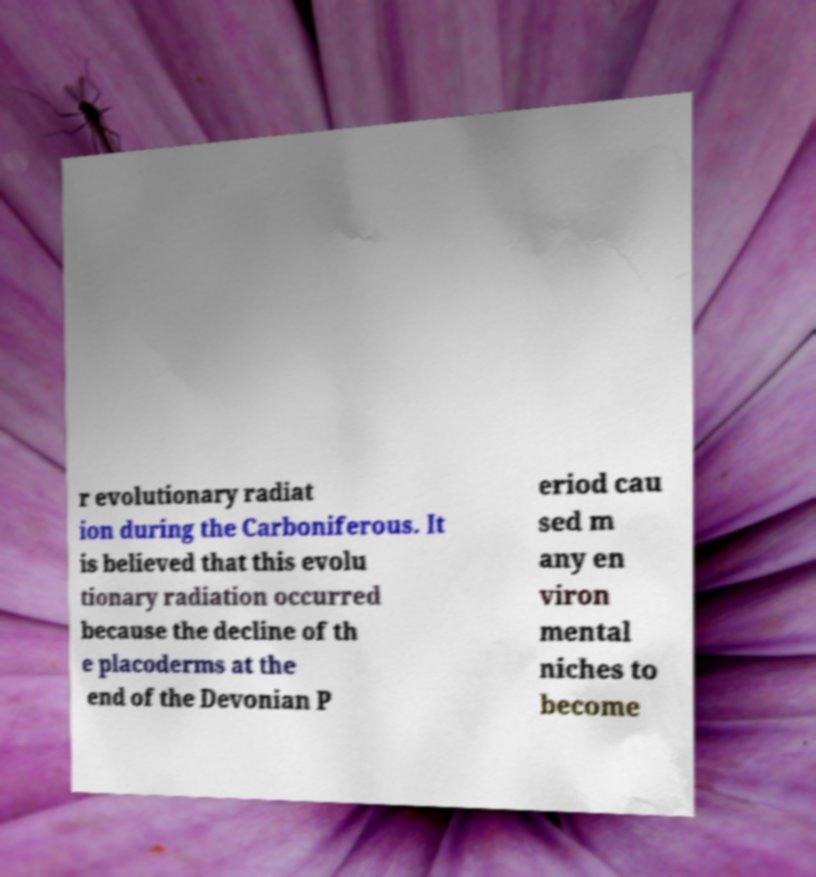Please read and relay the text visible in this image. What does it say? r evolutionary radiat ion during the Carboniferous. It is believed that this evolu tionary radiation occurred because the decline of th e placoderms at the end of the Devonian P eriod cau sed m any en viron mental niches to become 